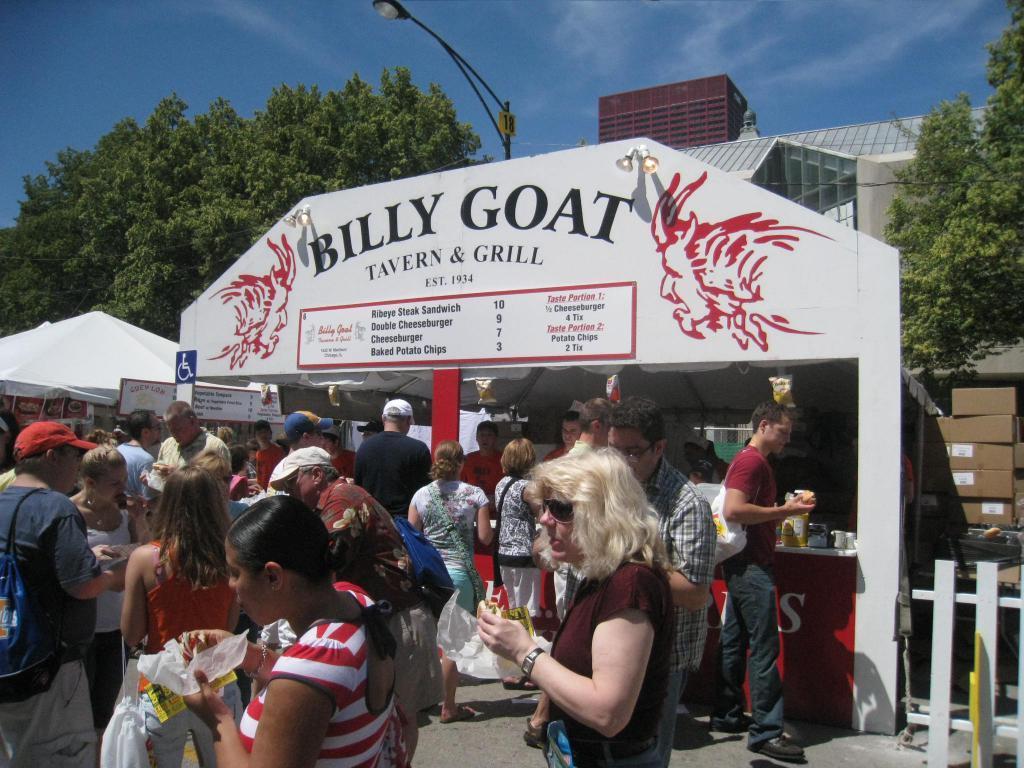Please provide a concise description of this image. In this image we can see one building, two shops, one streetlight, four small light attached to the wall, some text written on the shop board, one board and one number board is attached to the streetlight and so many people are standing on a road, some people are wearing bags and some people are eating. Some objects are on the surface. Two poles are there, four packets hanging on the shop wall and some objects are on the table. 